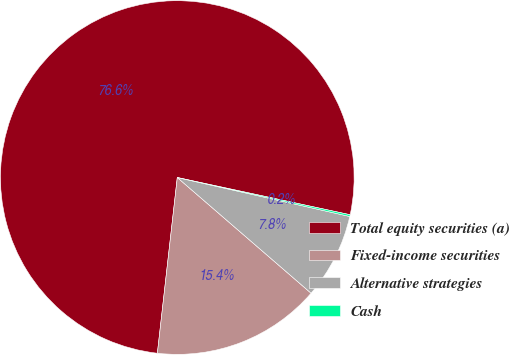Convert chart to OTSL. <chart><loc_0><loc_0><loc_500><loc_500><pie_chart><fcel>Total equity securities (a)<fcel>Fixed-income securities<fcel>Alternative strategies<fcel>Cash<nl><fcel>76.58%<fcel>15.45%<fcel>7.81%<fcel>0.16%<nl></chart> 